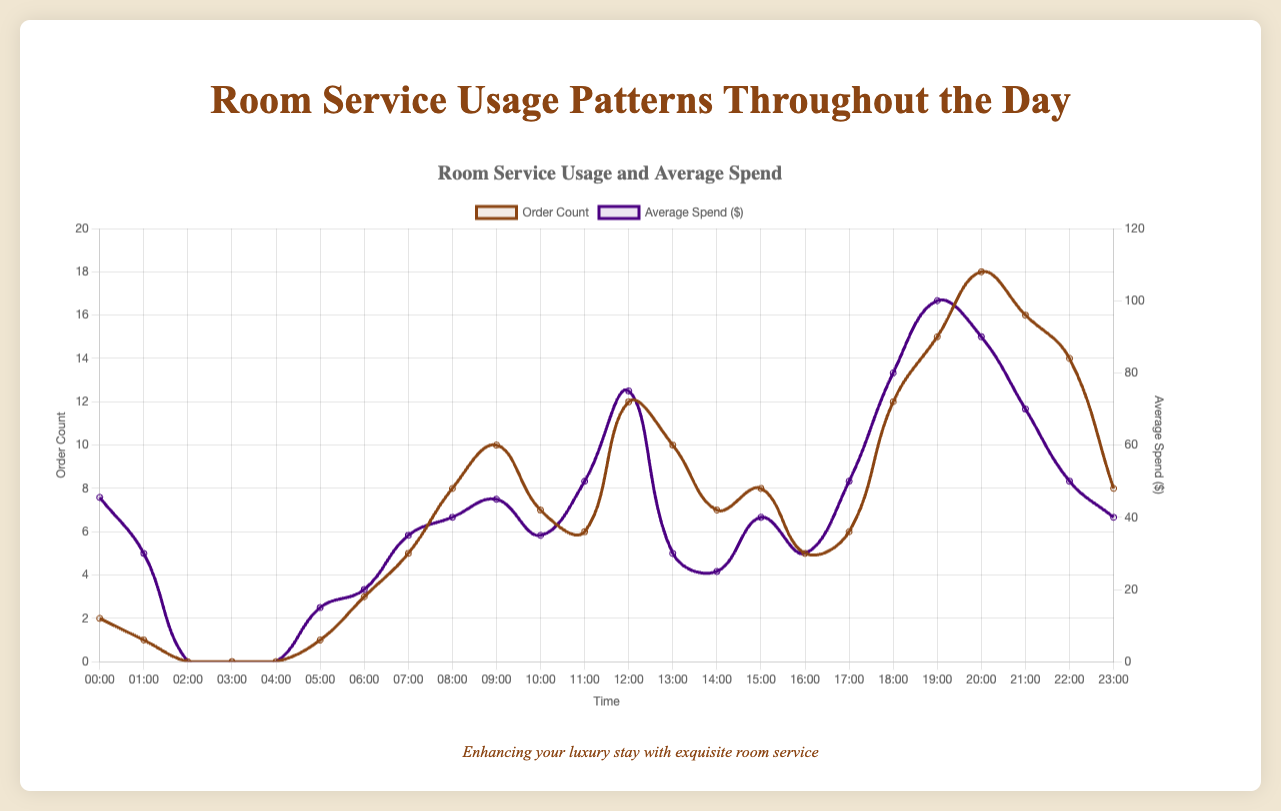What time of day has the highest order count for room service? The time of day with the highest order count is when the peak of the "Order Count" curve is observed. From the plot, this peak is at 20:00 with an order count of 18.
Answer: 20:00 What is the average spend during the hour with the highest order count? The hour with the highest order count is 20:00. The "Average Spend" for this hour is displayed in the data point at that time, which is $90.00.
Answer: $90.00 How does the order count at 09:00 compare to the order count at 19:00? The order count at 09:00 is 10, and at 19:00 it is 15. Comparing the two, the order count at 19:00 is higher than at 09:00.
Answer: 19:00 > 09:00 During which hours is the average spend exactly $50.00? By examining the "Average Spend" curve, we can see that the average spend is $50.00 at 11:00 and 22:00.
Answer: 11:00 and 22:00 What is the difference in average spend between 13:00 and 18:00? The average spend at 13:00 is $30.00, while at 18:00 it is $80.00. The difference is calculated as $80.00 - $30.00 = $50.00.
Answer: $50.00 What popular items are ordered during the peak hour for average spend? The peak hour for average spend is 19:00 with $100. The popular items during this hour are "Steak" and "Red Wine."
Answer: Steak and Red Wine Which hour has the lowest order count and what is the popular item during that hour? The hours with the lowest order counts are 02:00, 03:00, and 04:00, all having an order count of 0. There are no popular items during these hours since no orders were made.
Answer: 02:00, 03:00, 04:00; None What time shows the highest average spend, and what is the main dish ordered during this time? The highest average spend is at 19:00, where the average spend is $100.00. The main dish ordered during this time is "Steak."
Answer: 19:00; Steak Considering times 06:00 to 08:00, what is the total order count? Summing up the order counts from 06:00 (3), 07:00 (5), and 08:00 (8), results in a total order count of 3 + 5 + 8 = 16.
Answer: 16 What is the ratio of order count between 21:00 and 23:00? The order count at 21:00 is 16 and at 23:00 is 8. The ratio is calculated as 16 / 8 = 2.
Answer: 2 